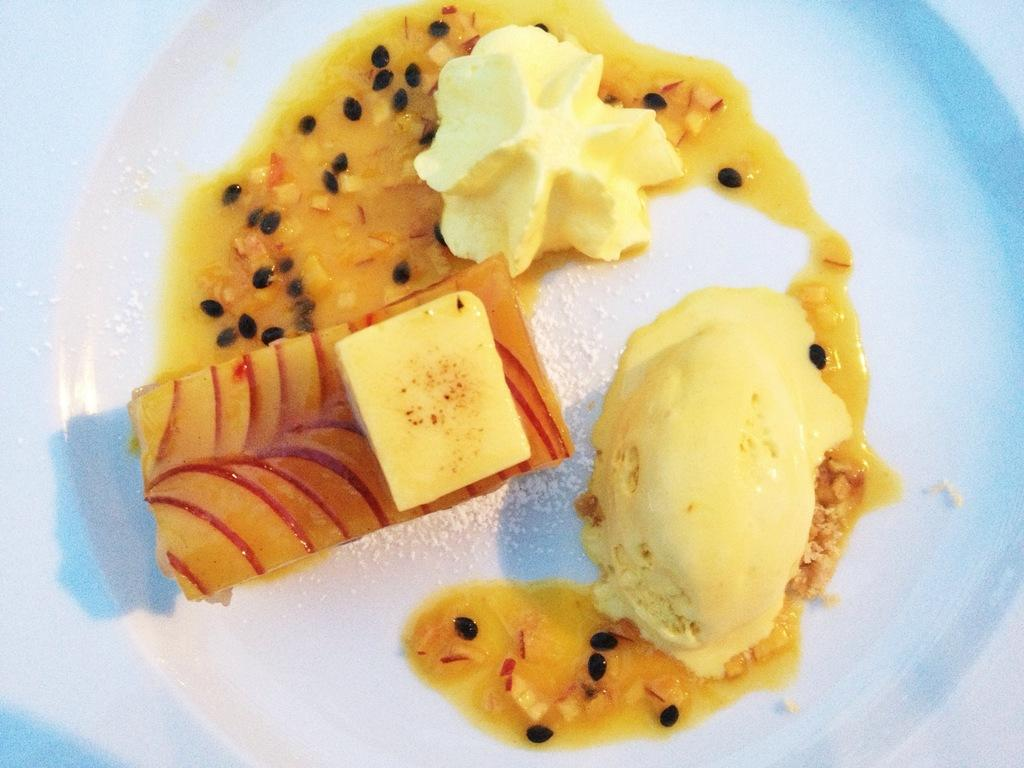What type of dessert is visible in the image? There is ice cream in the image. What other treats can be seen in the image? There are sweets in the image. What else is on the plate in the image besides ice cream and sweets? There are other food items on a plate in the image. What type of power source is visible in the image? There is no power source visible in the image; it features ice cream, sweets, and other food items. Can you describe the facial expressions of the people in the image? There are no people present in the image, so facial expressions cannot be described. 